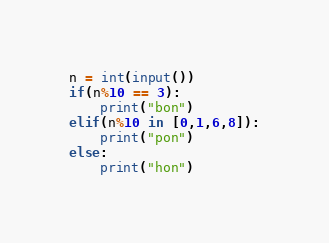<code> <loc_0><loc_0><loc_500><loc_500><_Python_>n = int(input())
if(n%10 == 3):
    print("bon")
elif(n%10 in [0,1,6,8]):
    print("pon")
else:
    print("hon")
</code> 